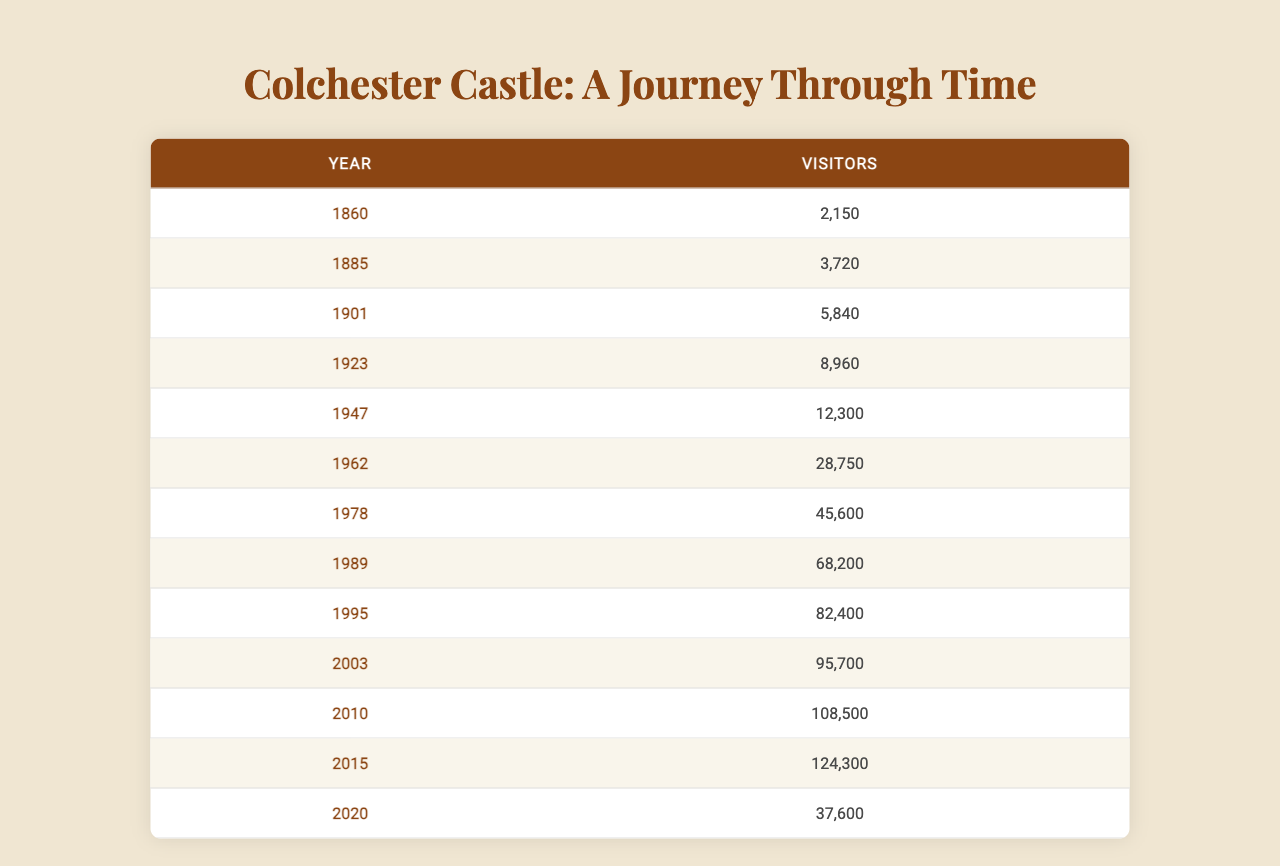What was the visitor count in 1901? According to the table, the number of visitors in 1901 is directly listed as 5840.
Answer: 5840 What year had the highest visitor count? By reviewing the table, 2015 stands out with the highest visitor count of 124300.
Answer: 2015 How many visitors did Colchester Castle have in 1962 compared to 1947? The count for 1962 is 28750 and for 1947 it is 12300. The difference is 28750 - 12300 = 16450 more visitors in 1962.
Answer: 16450 What is the average number of visitors between 1885 and 2010, inclusive? The visitor counts are 3720 (1885), 5840 (1901), 8960 (1923), 12300 (1947), 28750 (1962), 45600 (1978), 68200 (1989), 82400 (1995), 95700 (2003), and 108500 (2010). Summing these yields 342370. There are 10 years, so the average is 342370 / 10 = 34237.
Answer: 34237 Did the number of visitors decrease from 2015 to 2020? The table shows 124300 visitors in 2015 and 37600 in 2020. Since 37600 is less than 124300, it confirms that the number decreased.
Answer: Yes What was the total number of visitors in the years 1978 and 1989? Looking at the table, 1978 had 45600 visitors and 1989 had 68200 visitors. The total is 45600 + 68200 = 113800.
Answer: 113800 How much did the visitor count increase from 1860 to 2010? In 1860, there were 2150 visitors and by 2010 this number rose to 108500. The increase is calculated as 108500 - 2150 = 106350.
Answer: 106350 What percentage of visitors in 2010 is the visitor count for 1860? The number of visitors in 1860 was 2150 and in 2010 it was 108500. The percentage is calculated as (2150 / 108500) * 100 ≈ 1.98%.
Answer: Approximately 1.98% List the years when the visitor numbers were over 50000. By checking the table, the years are 1978 (45600), 1989 (68200), 1995 (82400), 2003 (95700), 2010 (108500), and 2015 (124300). Only the years from 1989 onwards are over 50000.
Answer: 1989, 1995, 2003, 2010, 2015 What was the visitor count in 1947 as a percentage of visitors in 1962? In 1947 there were 12300 visitors and in 1962 there were 28750. The percentage is calculated as (12300 / 28750) * 100 ≈ 42.8%.
Answer: Approximately 42.8% 